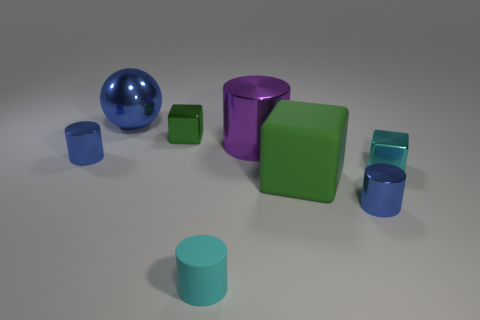How many objects are cyan things or purple things?
Provide a succinct answer. 3. Are there any other things that are made of the same material as the cyan cylinder?
Offer a terse response. Yes. Are there fewer purple shiny cylinders that are on the left side of the large purple thing than shiny spheres?
Ensure brevity in your answer.  Yes. Is the number of big purple cylinders in front of the tiny cyan block greater than the number of large green matte things on the left side of the large purple metal object?
Ensure brevity in your answer.  No. Are there any other things that are the same color as the large matte block?
Provide a short and direct response. Yes. What is the green object that is on the right side of the cyan rubber cylinder made of?
Offer a very short reply. Rubber. Does the cyan shiny block have the same size as the cyan cylinder?
Make the answer very short. Yes. How many other objects are there of the same size as the cyan matte cylinder?
Make the answer very short. 4. Do the matte block and the large sphere have the same color?
Give a very brief answer. No. There is a tiny blue metal thing that is on the left side of the green matte cube in front of the small cylinder left of the cyan rubber cylinder; what is its shape?
Provide a short and direct response. Cylinder. 